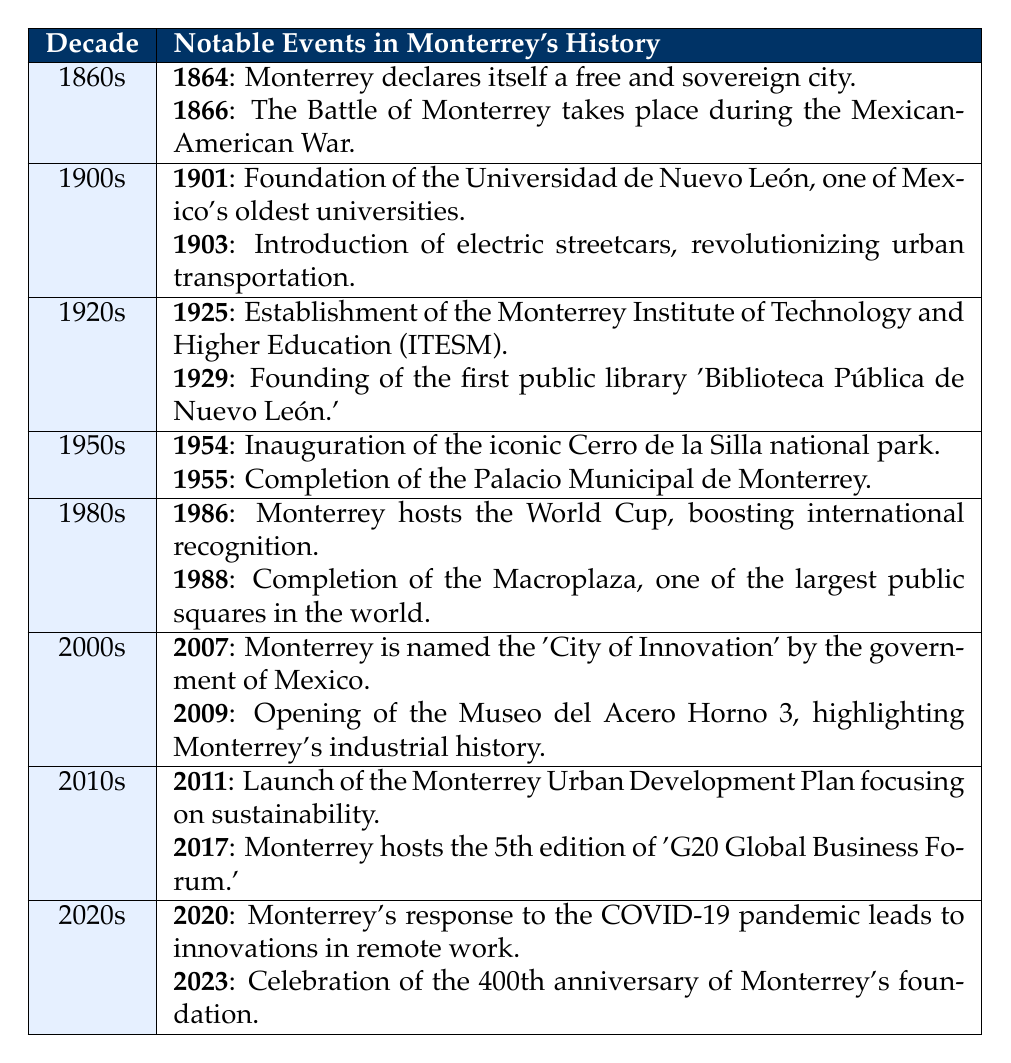What notable event happened in Monterrey in 1864? The table lists the event for 1864 under the 1860s decade as "Monterrey declares itself a free and sovereign city."
Answer: Monterrey declares itself a free and sovereign city Which decade saw the establishment of the first public library in Monterrey? The 1920s decade is specified with the event "Founding of the first public library 'Biblioteca Pública de Nuevo León'" in 1929.
Answer: 1920s True or False: The Battle of Monterrey took place in the 1870s. The table shows that the Battle of Monterrey occurred in 1866, which is in the 1860s, thus the statement is false.
Answer: False How many notable events are recorded in the 1980s? The 1980s decade has two events listed: one for 1986 and another for 1988. We count these events to determine the total in that decade.
Answer: 2 Which decade had the most recent significant event listed? The most current decade listed is the 2020s, with the most recent event being the celebration of the 400th anniversary of Monterrey's foundation in 2023.
Answer: 2020s What was the main improvement in urban transportation introduced in 1903? The event in 1903 noted in the table was "Introduction of electric streetcars, revolutionizing urban transportation."
Answer: Electric streetcars In which decade were the Cerro de la Silla national park inaugurated and the Palacio Municipal de Monterrey completed? Both events occurred in the 1950s; the national park was inaugurated in 1954 and the Palacio Municipal completed in 1955.
Answer: 1950s How does 2011's event of launching the Monterrey Urban Development Plan relate to sustainability? The 2011 event explicitly states it focuses on sustainability, indicating that the plan was aimed at improving sustainable practices in Monterrey.
Answer: Focus on sustainability What significant international event did Monterrey host in 1986? The table describes the event from 1986 as Monterrey hosting the World Cup, which significantly boosted its recognition internationally.
Answer: World Cup Count the events that mentioned educational institutions in Monterrey's history. There are three events related to educational institutions: the foundation of Universidad de Nuevo León in 1901, the establishment of ITESM in 1925, and the mention of the foundation of the public library relates to education. Therefore, there are two educational institutions listed explicitly.
Answer: 2 What is the relationship between the 2007 event and Monterrey's reputation? The event in 2007, stating Monterrey was named the "City of Innovation," suggests a positive change in its global reputation in terms of technological and innovative strides, indicating a shift in perception favoring its advancements.
Answer: City of Innovation 